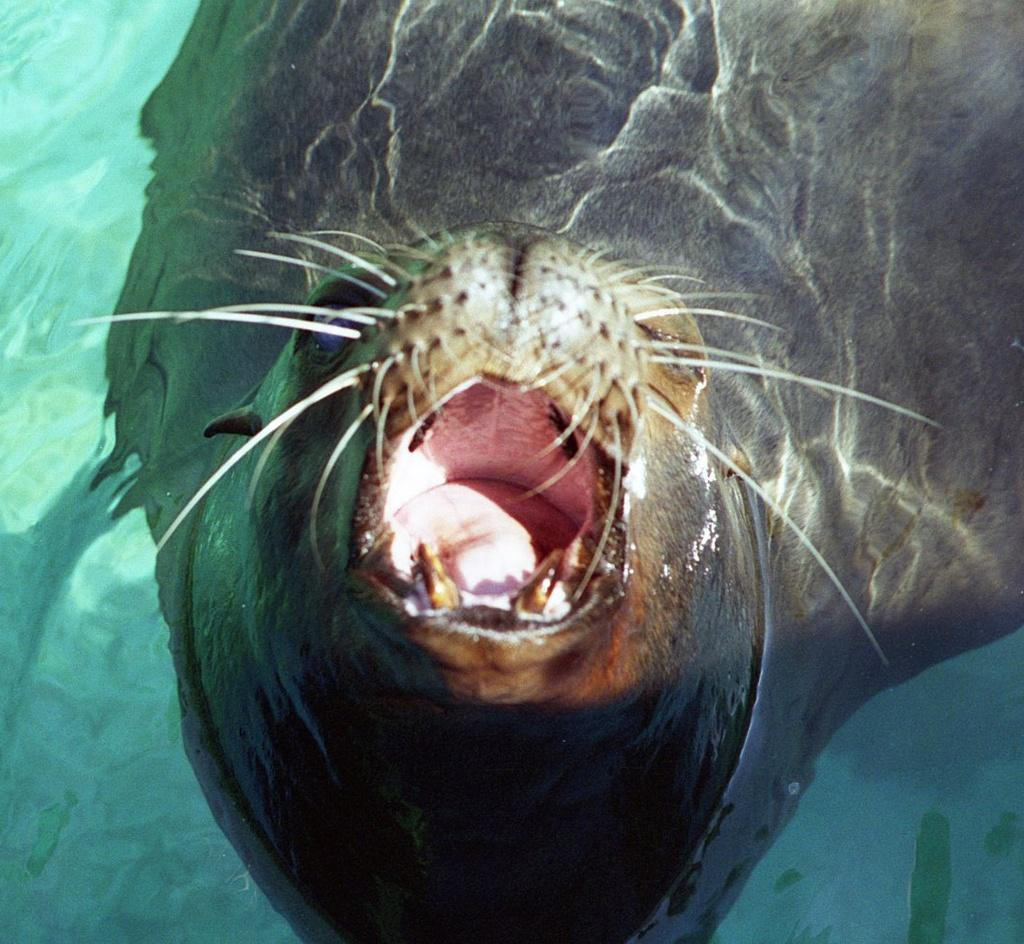What type of animal can be seen in the image? There is a seal in the water in the image. What is the seal's environment in the image? The seal is in the water in the image. What type of smoke can be seen coming from the seal in the image? There is no smoke present in the image, and the seal is not producing any smoke. 